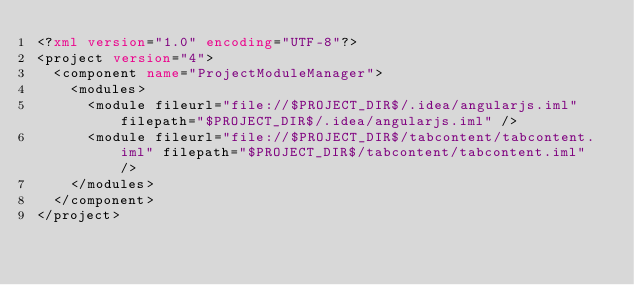Convert code to text. <code><loc_0><loc_0><loc_500><loc_500><_XML_><?xml version="1.0" encoding="UTF-8"?>
<project version="4">
  <component name="ProjectModuleManager">
    <modules>
      <module fileurl="file://$PROJECT_DIR$/.idea/angularjs.iml" filepath="$PROJECT_DIR$/.idea/angularjs.iml" />
      <module fileurl="file://$PROJECT_DIR$/tabcontent/tabcontent.iml" filepath="$PROJECT_DIR$/tabcontent/tabcontent.iml" />
    </modules>
  </component>
</project></code> 